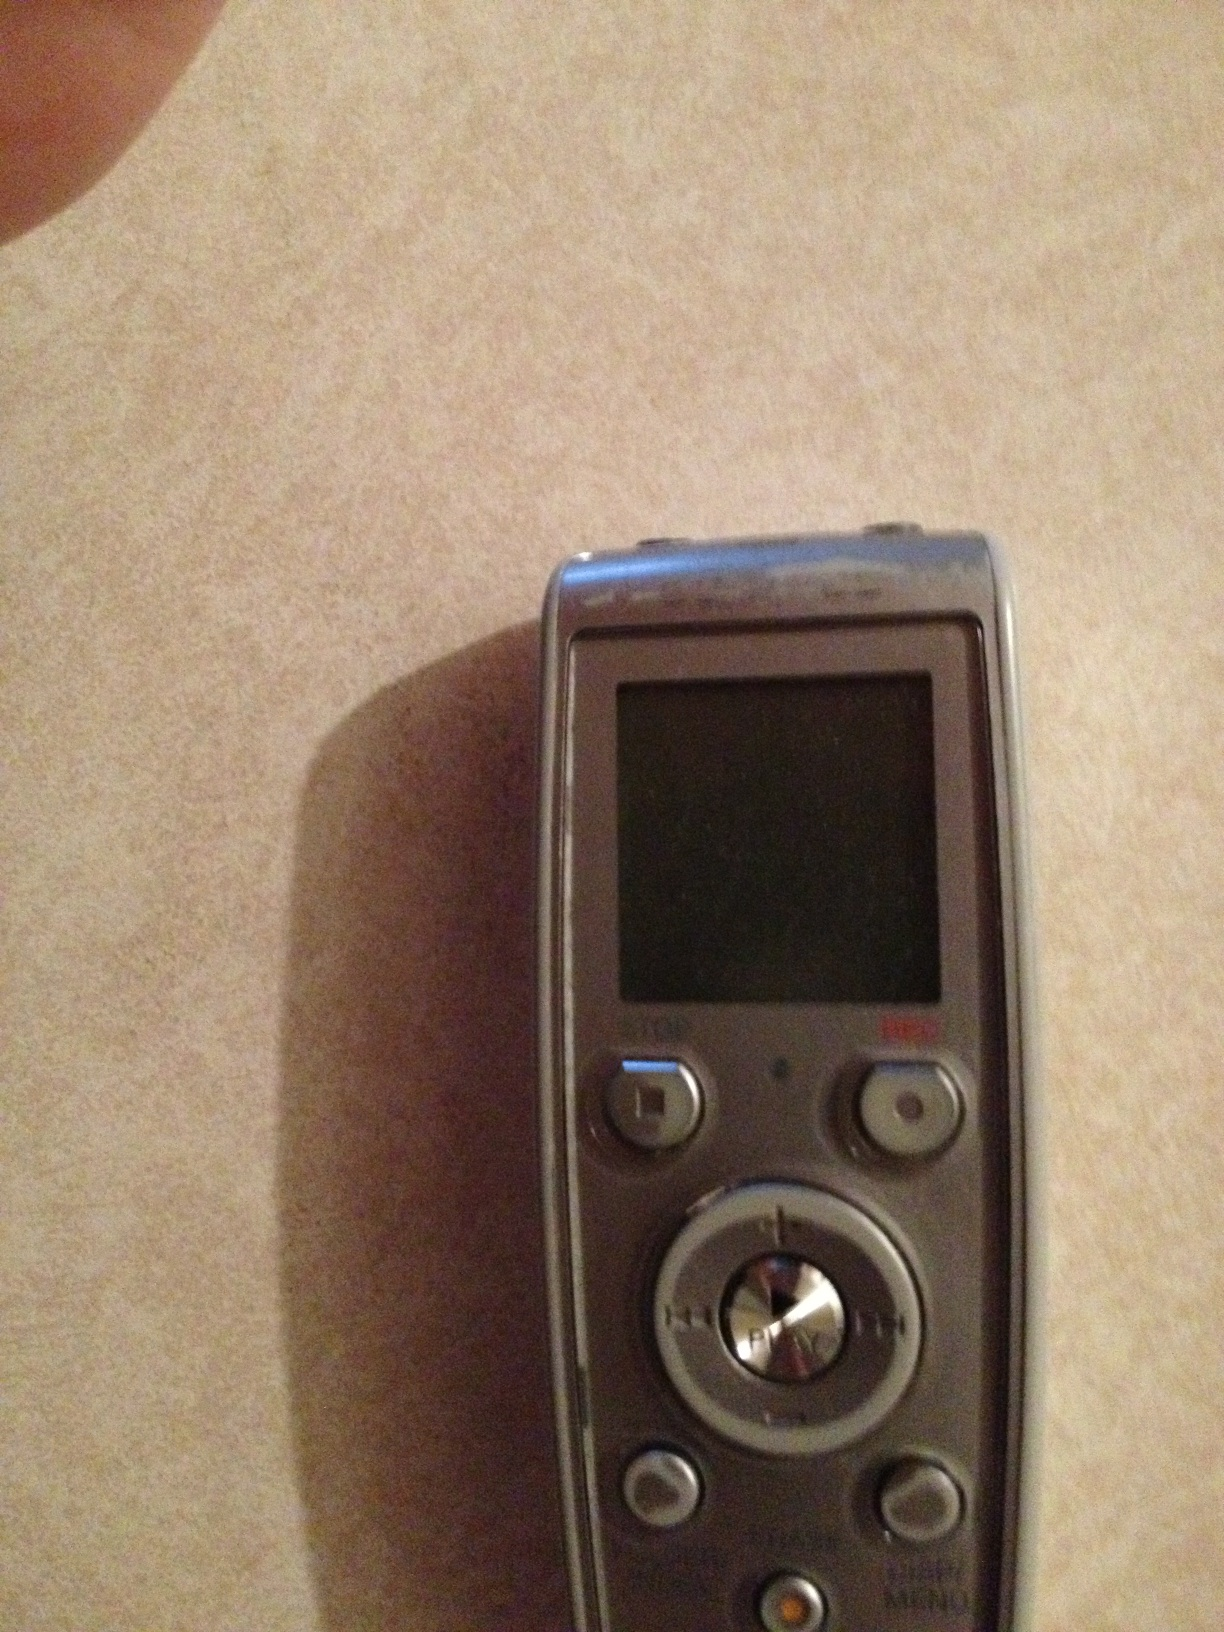Can you describe some possible uses for this device? This digital voice recorder can be used in various scenarios. For example, journalists might use it to record interviews, students to capture lectures, and professionals to record meetings or voice notes. Its portable nature makes it handy for anyone needing to record audio on the go. What are the standout features of this recorder? This recorder features a clear LCD screen for status information, buttons for easy operation, and a built-in microphone for quality audio capture. It also likely includes options for different recording modes, internal memory storage, and possibly an expandable memory card slot for additional storage. The buttons for play, stop, and record functions make it user-friendly. How would you compare this to the modern recording apps on smartphones? While modern smartphones and their recording apps provide convenience, digital voice recorders like this one often offer superior audio quality and longer recording times. They also come with specialized microphones that can better capture nuances in audio. Additionally, physical buttons on recorders can be easier to use in situations where operating touchscreens is impractical. Imagine if this device could also convert speech to text, how would that change its utility? If this device could convert speech to text, it would be incredibly useful for transcribing lectures and interviews into written documents, saving time and effort. It could also benefit individuals with hearing impairments by providing real-time text of spoken content. Moreover, it might enhance productivity for professionals by allowing them to dictate and instantly record written notes. 